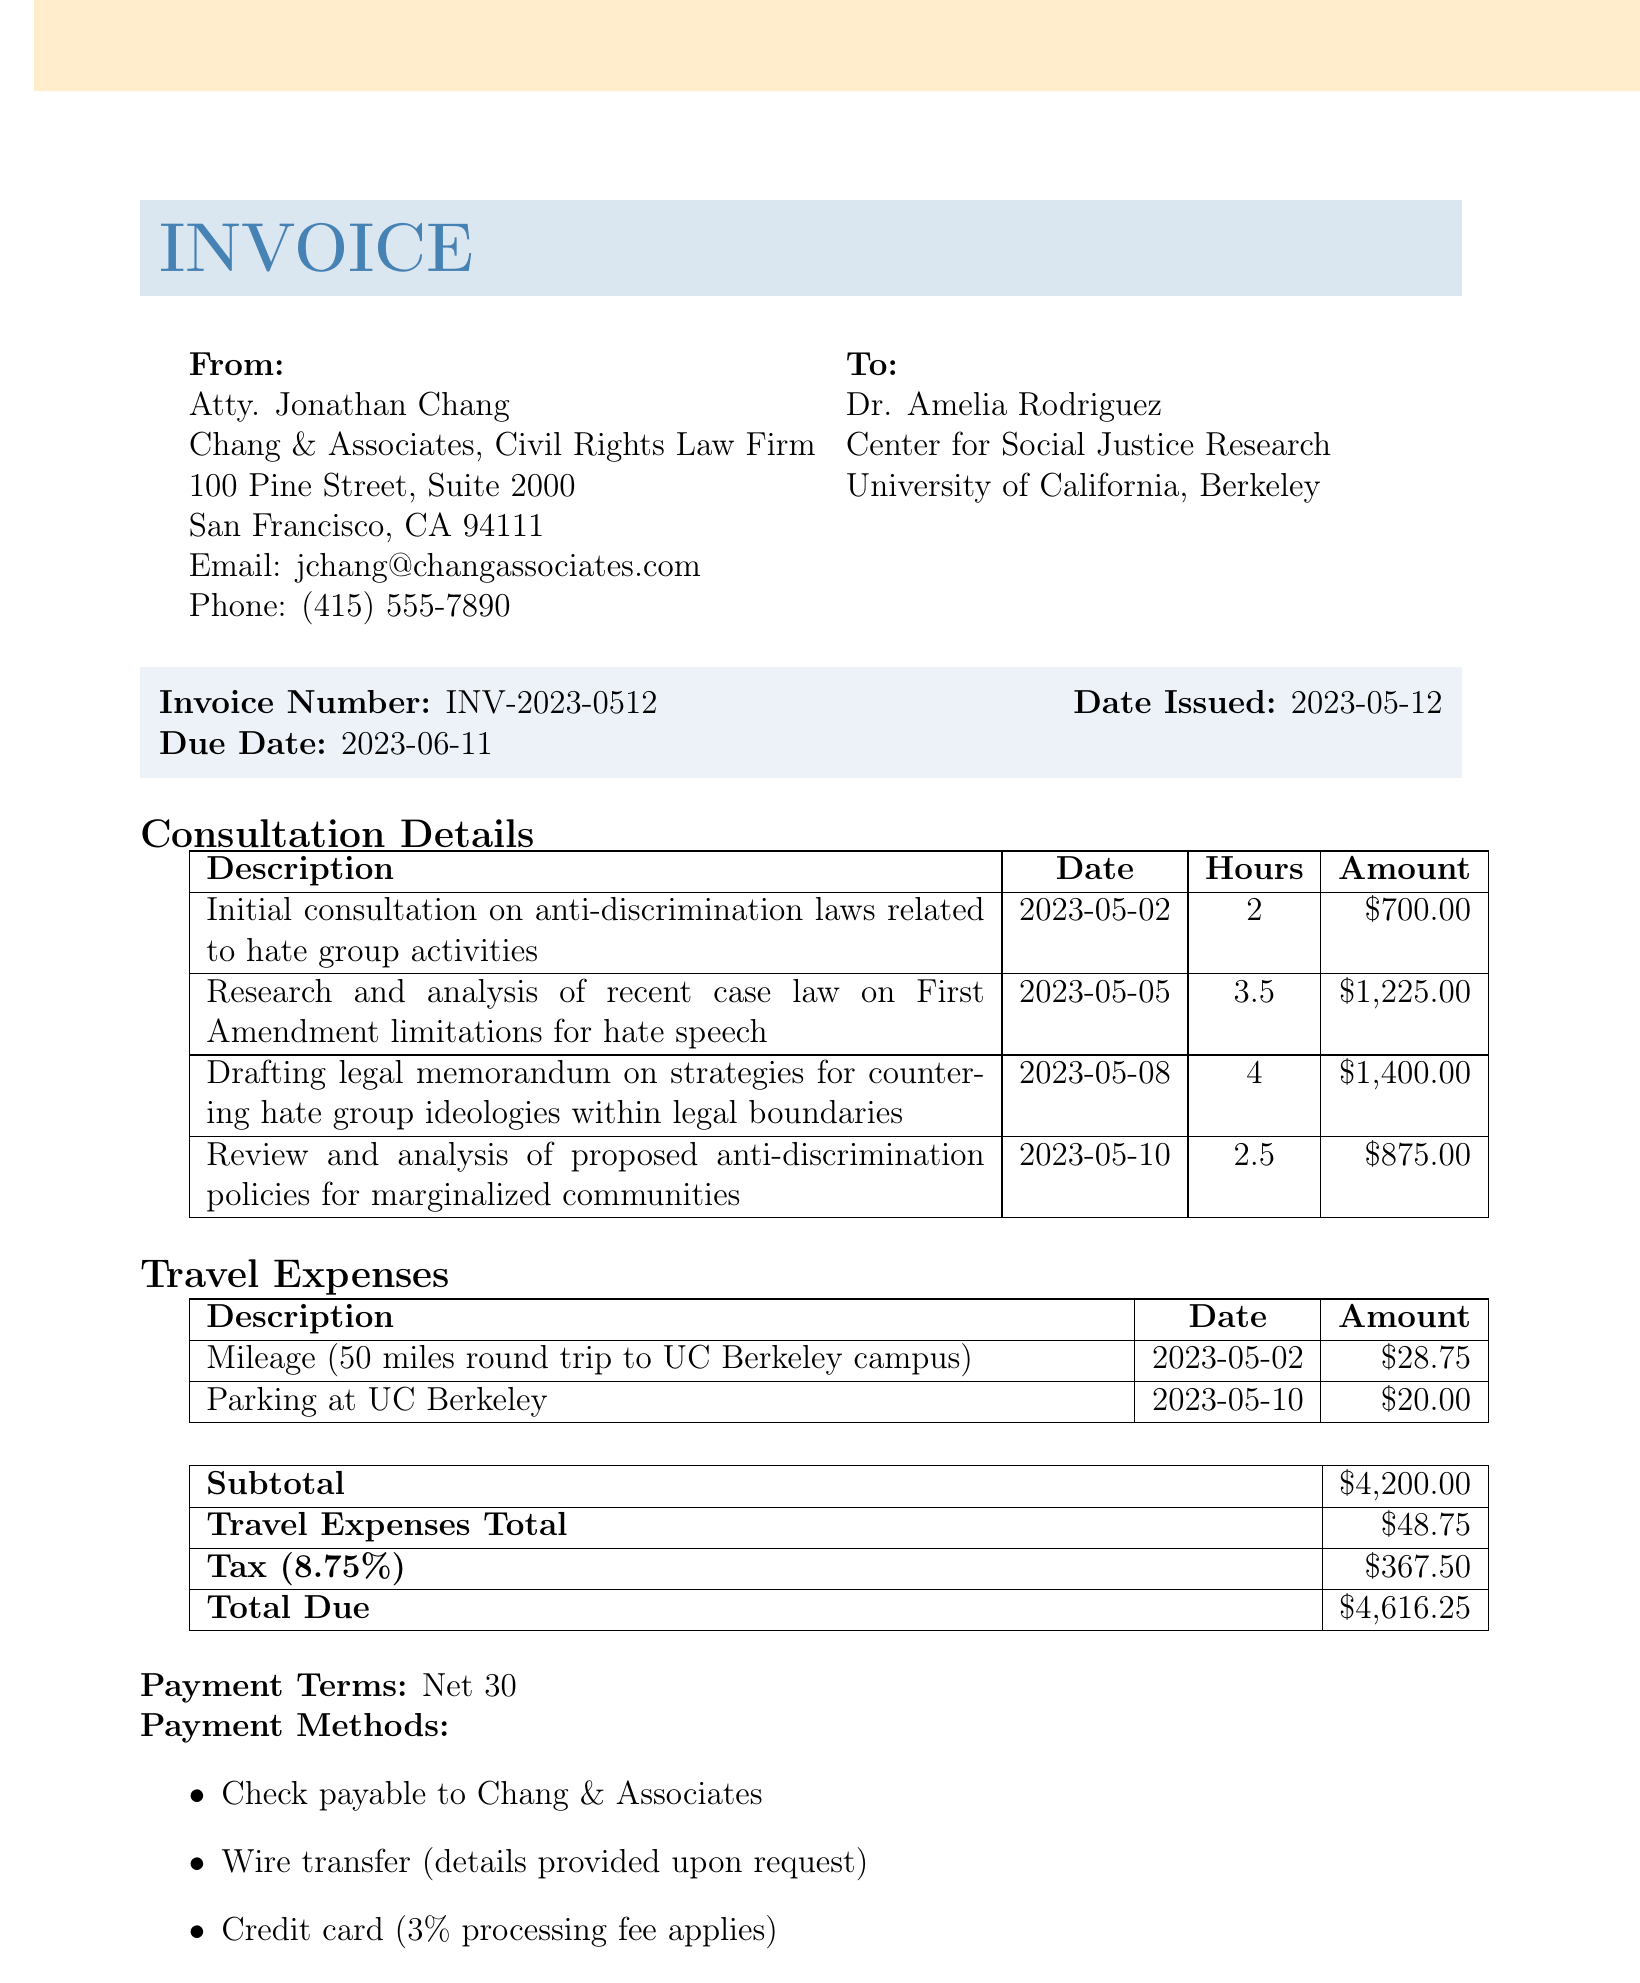What is the invoice number? The invoice number can be found in the header section of the document, listed as "Invoice Number."
Answer: INV-2023-0512 Who is the client? The client is listed in the "To:" section of the document.
Answer: Dr. Amelia Rodriguez What is the total due? The total due is the final amount listed at the bottom of the invoice.
Answer: 4,616.25 How many hours were charged for drafting the legal memorandum? The hours for drafting the legal memorandum can be found in the consultation details section associated with that specific task.
Answer: 4 What is the tax rate applied to this invoice? The tax rate is mentioned in the summary section listing the tax calculation details.
Answer: 8.75% Which payment method includes a processing fee? Payment methods are listed at the bottom of the document, where one type mentions a processing fee.
Answer: Credit card What is the total amount for travel expenses? The total amount for travel expenses is specified in the summary section right before the total due.
Answer: 48.75 How many hours were spent on research and analysis of case law? The consultation details list the hours spent on each task, including research and analysis of case law.
Answer: 3.5 